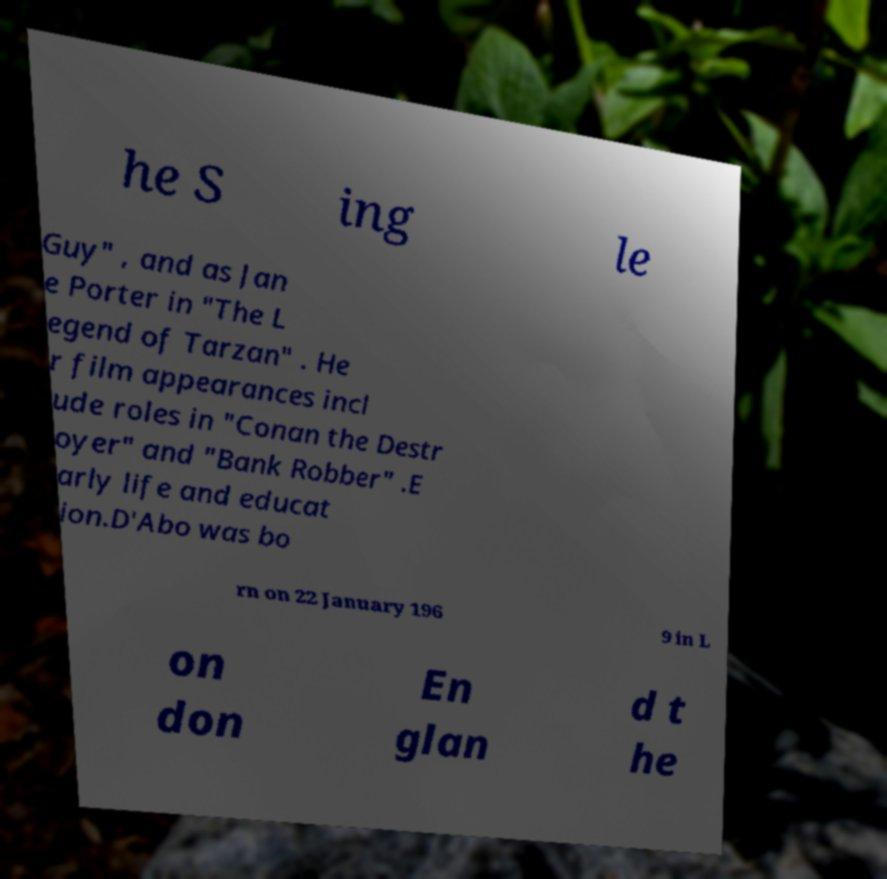Could you assist in decoding the text presented in this image and type it out clearly? he S ing le Guy" , and as Jan e Porter in "The L egend of Tarzan" . He r film appearances incl ude roles in "Conan the Destr oyer" and "Bank Robber" .E arly life and educat ion.D'Abo was bo rn on 22 January 196 9 in L on don En glan d t he 